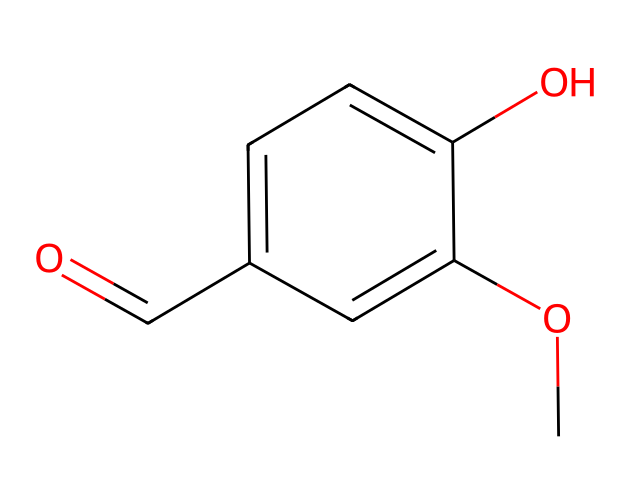What is the name of the chemical represented by this SMILES notation? The SMILES notation indicates a compound with specific functional groups. Upon analysis, it corresponds to vanillin, which is well-known as the primary component of vanilla flavoring.
Answer: vanillin How many carbon atoms are in the chemical structure of vanillin? By examining the SMILES representation, we can count the carbon atoms. There are eight carbon atoms present in this structure, as indicated by the "c" (aromatic carbon) and "C" (aliphatic carbon).
Answer: eight What is the total number of oxygen atoms in vanillin? Looking closely at the SMILES representation, there are two occurrences of the "O" character which indicates the presence of two oxygen atoms in the chemical structure of vanillin.
Answer: two What type of functional groups are present in vanillin? Analyzing the SMILES structure reveals that vanillin has an aldehyde group (noted by O=) and a hydroxy group (-OH), characteristic of the chemical properties of vanillin that contribute to its flavor.
Answer: aldehyde and hydroxy Does vanillin contain any aromatic rings? In the SMILES notation, multiple "c" characters signify that the structure includes aromatic carbon atoms, indicating the presence of aromatic rings in vanillin’s structure.
Answer: yes What type of hydrocarbon is vanillin classified as? Based on the structure and functional groups, vanillin is classified as an aromatic hydrocarbon due to the presence of an aromatic ring containing carbon atoms, along with its specific functional groups.
Answer: aromatic hydrocarbon 